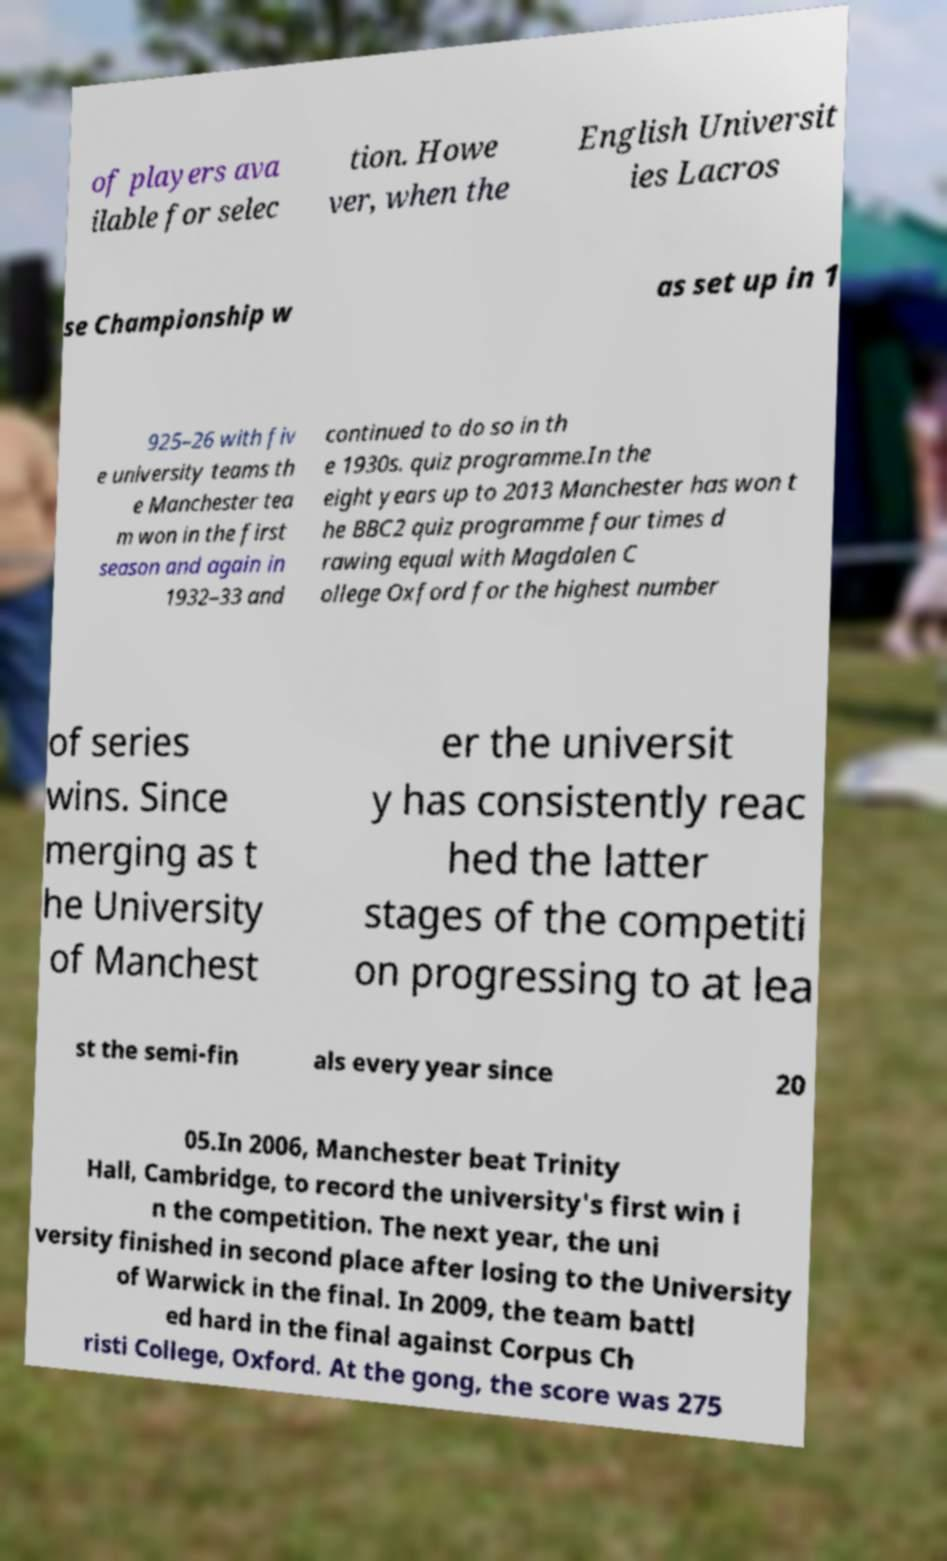There's text embedded in this image that I need extracted. Can you transcribe it verbatim? of players ava ilable for selec tion. Howe ver, when the English Universit ies Lacros se Championship w as set up in 1 925–26 with fiv e university teams th e Manchester tea m won in the first season and again in 1932–33 and continued to do so in th e 1930s. quiz programme.In the eight years up to 2013 Manchester has won t he BBC2 quiz programme four times d rawing equal with Magdalen C ollege Oxford for the highest number of series wins. Since merging as t he University of Manchest er the universit y has consistently reac hed the latter stages of the competiti on progressing to at lea st the semi-fin als every year since 20 05.In 2006, Manchester beat Trinity Hall, Cambridge, to record the university's first win i n the competition. The next year, the uni versity finished in second place after losing to the University of Warwick in the final. In 2009, the team battl ed hard in the final against Corpus Ch risti College, Oxford. At the gong, the score was 275 